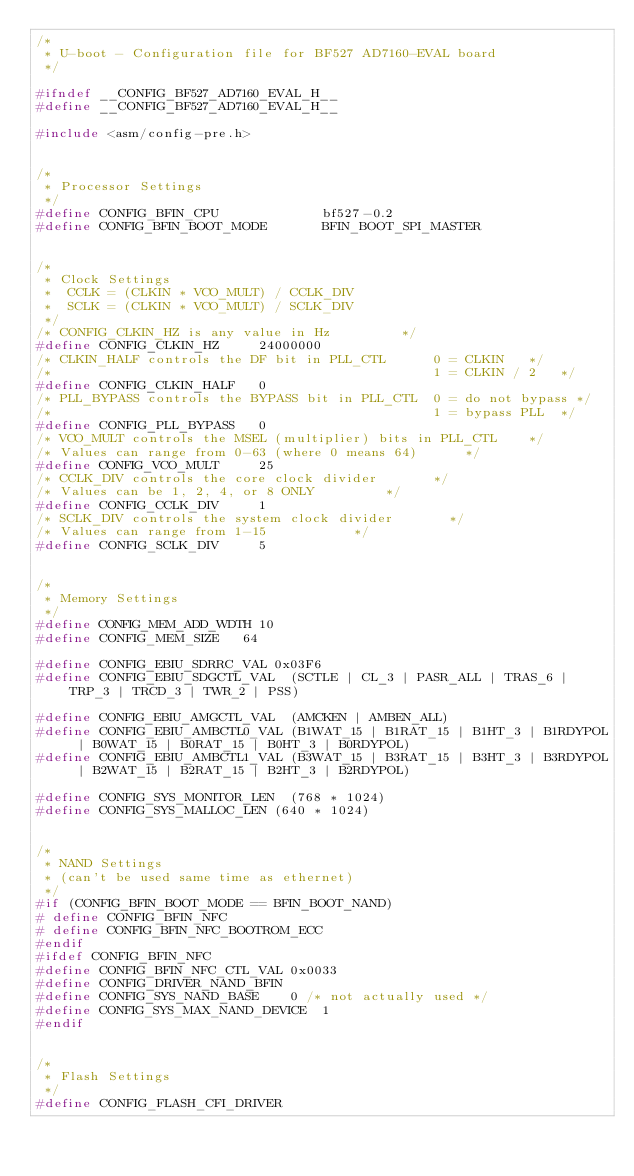<code> <loc_0><loc_0><loc_500><loc_500><_C_>/*
 * U-boot - Configuration file for BF527 AD7160-EVAL board
 */

#ifndef __CONFIG_BF527_AD7160_EVAL_H__
#define __CONFIG_BF527_AD7160_EVAL_H__

#include <asm/config-pre.h>


/*
 * Processor Settings
 */
#define CONFIG_BFIN_CPU             bf527-0.2
#define CONFIG_BFIN_BOOT_MODE       BFIN_BOOT_SPI_MASTER


/*
 * Clock Settings
 *	CCLK = (CLKIN * VCO_MULT) / CCLK_DIV
 *	SCLK = (CLKIN * VCO_MULT) / SCLK_DIV
 */
/* CONFIG_CLKIN_HZ is any value in Hz					*/
#define CONFIG_CLKIN_HZ			24000000
/* CLKIN_HALF controls the DF bit in PLL_CTL      0 = CLKIN		*/
/*                                                1 = CLKIN / 2		*/
#define CONFIG_CLKIN_HALF		0
/* PLL_BYPASS controls the BYPASS bit in PLL_CTL  0 = do not bypass	*/
/*                                                1 = bypass PLL	*/
#define CONFIG_PLL_BYPASS		0
/* VCO_MULT controls the MSEL (multiplier) bits in PLL_CTL		*/
/* Values can range from 0-63 (where 0 means 64)			*/
#define CONFIG_VCO_MULT			25
/* CCLK_DIV controls the core clock divider				*/
/* Values can be 1, 2, 4, or 8 ONLY					*/
#define CONFIG_CCLK_DIV			1
/* SCLK_DIV controls the system clock divider				*/
/* Values can range from 1-15						*/
#define CONFIG_SCLK_DIV			5


/*
 * Memory Settings
 */
#define CONFIG_MEM_ADD_WDTH	10
#define CONFIG_MEM_SIZE		64

#define CONFIG_EBIU_SDRRC_VAL	0x03F6
#define CONFIG_EBIU_SDGCTL_VAL	(SCTLE | CL_3 | PASR_ALL | TRAS_6 | TRP_3 | TRCD_3 | TWR_2 | PSS)

#define CONFIG_EBIU_AMGCTL_VAL	(AMCKEN | AMBEN_ALL)
#define CONFIG_EBIU_AMBCTL0_VAL	(B1WAT_15 | B1RAT_15 | B1HT_3 | B1RDYPOL | B0WAT_15 | B0RAT_15 | B0HT_3 | B0RDYPOL)
#define CONFIG_EBIU_AMBCTL1_VAL	(B3WAT_15 | B3RAT_15 | B3HT_3 | B3RDYPOL | B2WAT_15 | B2RAT_15 | B2HT_3 | B2RDYPOL)

#define CONFIG_SYS_MONITOR_LEN	(768 * 1024)
#define CONFIG_SYS_MALLOC_LEN	(640 * 1024)


/*
 * NAND Settings
 * (can't be used same time as ethernet)
 */
#if (CONFIG_BFIN_BOOT_MODE == BFIN_BOOT_NAND)
# define CONFIG_BFIN_NFC
# define CONFIG_BFIN_NFC_BOOTROM_ECC
#endif
#ifdef CONFIG_BFIN_NFC
#define CONFIG_BFIN_NFC_CTL_VAL	0x0033
#define CONFIG_DRIVER_NAND_BFIN
#define CONFIG_SYS_NAND_BASE		0 /* not actually used */
#define CONFIG_SYS_MAX_NAND_DEVICE	1
#endif


/*
 * Flash Settings
 */
#define CONFIG_FLASH_CFI_DRIVER</code> 